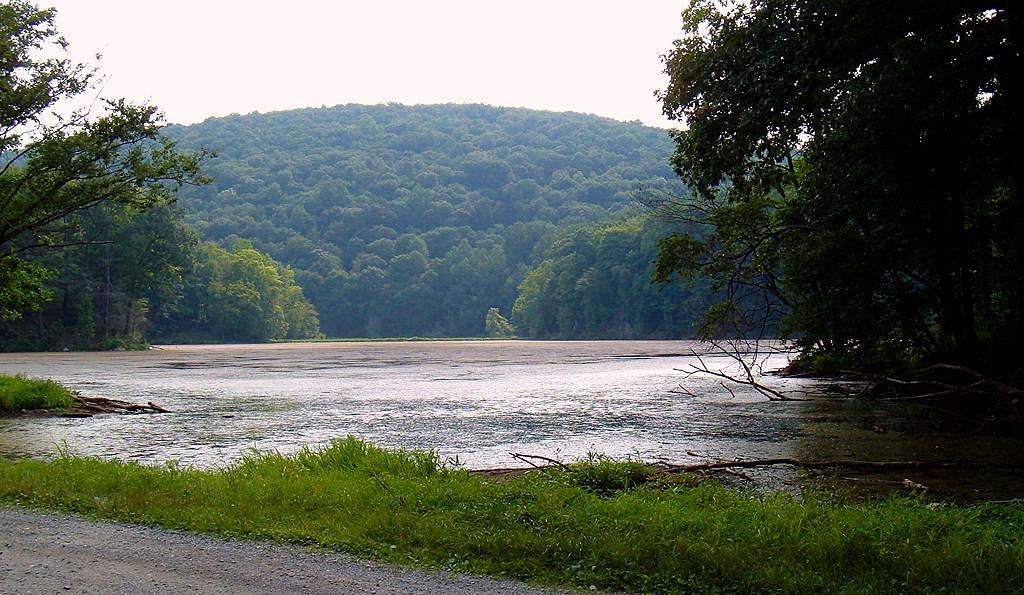How would you summarize this image in a sentence or two? In this picture we can observe a river. There is some grass on the land. We can observe a road here. In the background there are trees, hill and a sky. 